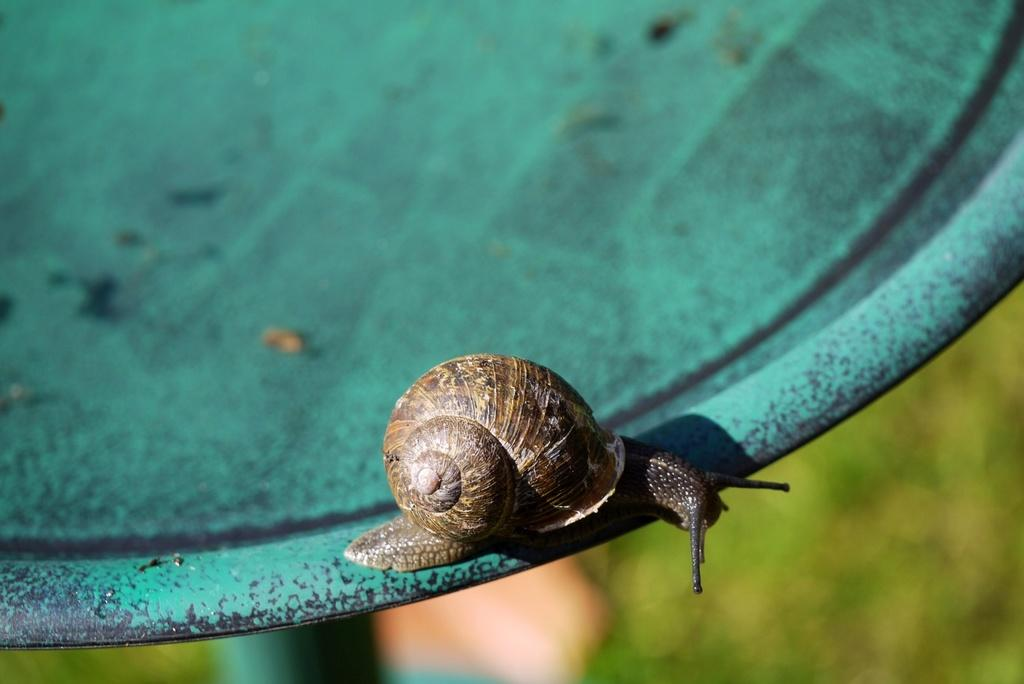What is the main subject of the image? There is a snail in the image. What is the snail doing in the image? The snail is crawling on a plate. Can you describe the background of the image? The background of the image is blurry. What type of oil can be seen dripping from the angle of the plate in the image? There is no oil or angle mentioned in the image; it only features a snail crawling on a plate with a blurry background. 